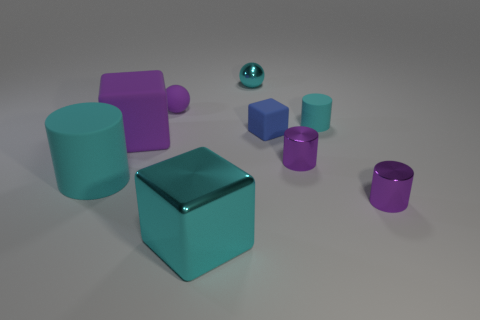What number of large rubber cylinders are left of the small purple rubber sphere that is on the right side of the purple matte cube?
Make the answer very short. 1. The large purple thing left of the large cyan thing that is right of the big cylinder that is on the left side of the blue object is what shape?
Offer a terse response. Cube. How big is the cyan shiny block?
Make the answer very short. Large. Are there any gray objects that have the same material as the big cyan block?
Offer a very short reply. No. The cyan thing that is the same shape as the small purple matte object is what size?
Offer a very short reply. Small. Are there the same number of small purple cylinders that are behind the purple matte block and small matte balls?
Your response must be concise. No. Do the cyan matte object left of the big cyan cube and the small purple rubber object have the same shape?
Make the answer very short. No. There is a large purple thing; what shape is it?
Make the answer very short. Cube. There is a tiny cyan object in front of the purple object behind the tiny blue object right of the cyan cube; what is it made of?
Provide a succinct answer. Rubber. There is a ball that is the same color as the big metal cube; what material is it?
Ensure brevity in your answer.  Metal. 